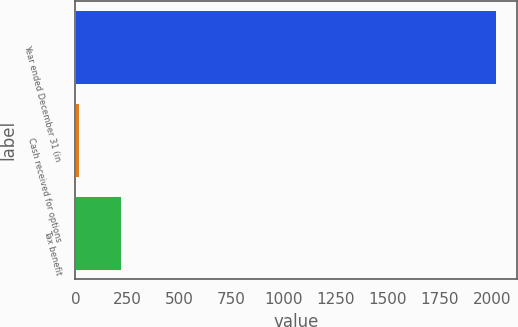Convert chart. <chart><loc_0><loc_0><loc_500><loc_500><bar_chart><fcel>Year ended December 31 (in<fcel>Cash received for options<fcel>Tax benefit<nl><fcel>2017<fcel>18<fcel>217.9<nl></chart> 